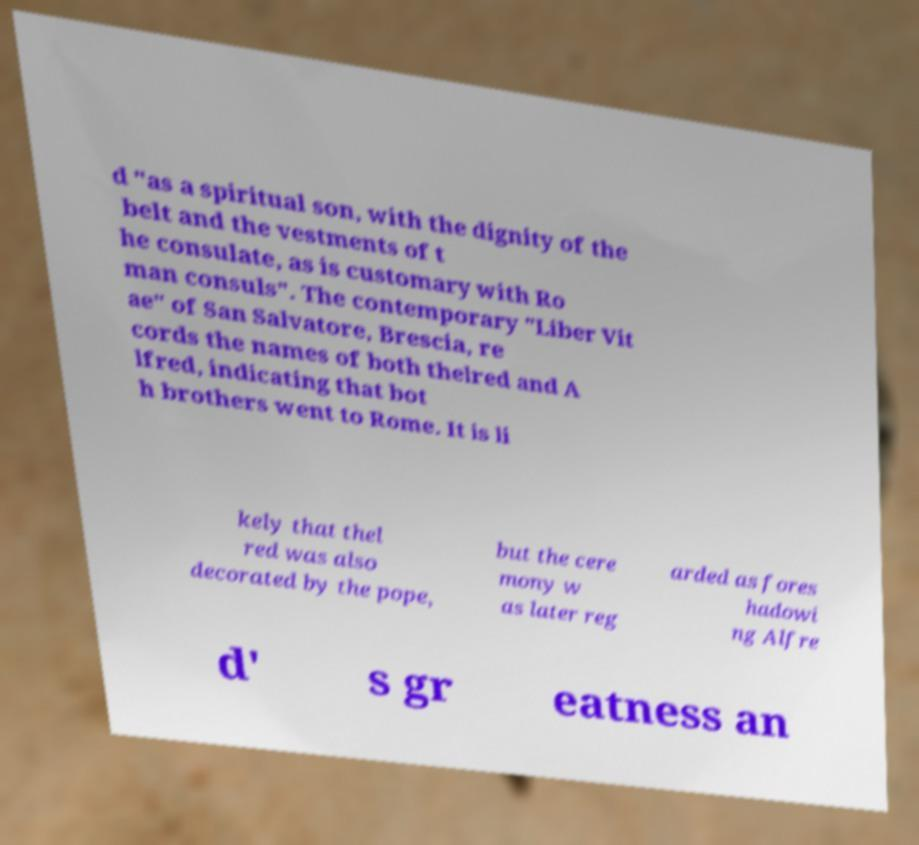Please read and relay the text visible in this image. What does it say? d "as a spiritual son, with the dignity of the belt and the vestments of t he consulate, as is customary with Ro man consuls". The contemporary "Liber Vit ae" of San Salvatore, Brescia, re cords the names of both thelred and A lfred, indicating that bot h brothers went to Rome. It is li kely that thel red was also decorated by the pope, but the cere mony w as later reg arded as fores hadowi ng Alfre d' s gr eatness an 